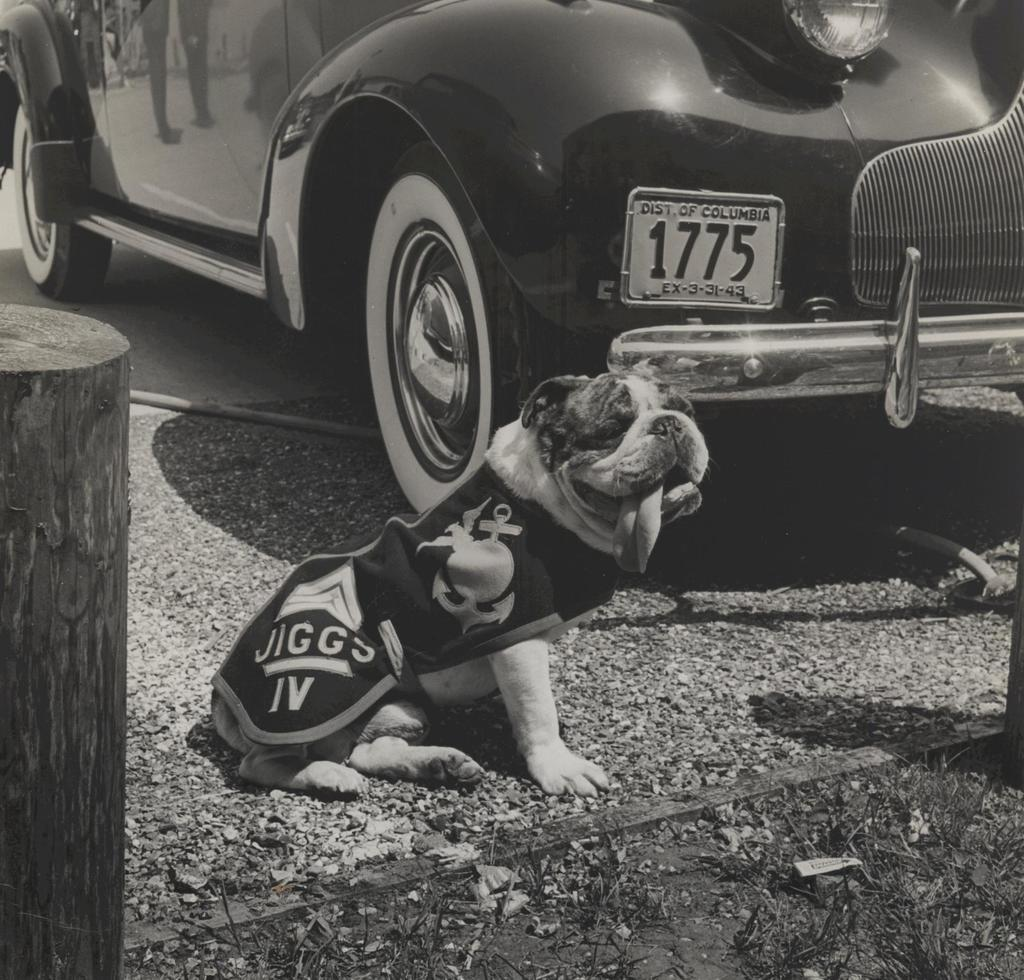What type of animal can be seen in the image? There is a dog in the image. What kind of natural elements are present in the image? There are stones and grass in the image. What is the wooden object in the image? The wooden object in the image is not specified, but it is mentioned as being present. What man-made object can be seen in the image? There is a car in the image. How many pages are visible in the image? There are no pages present in the image. What is the size of the rainstorm in the image? There is no rainstorm present in the image. 